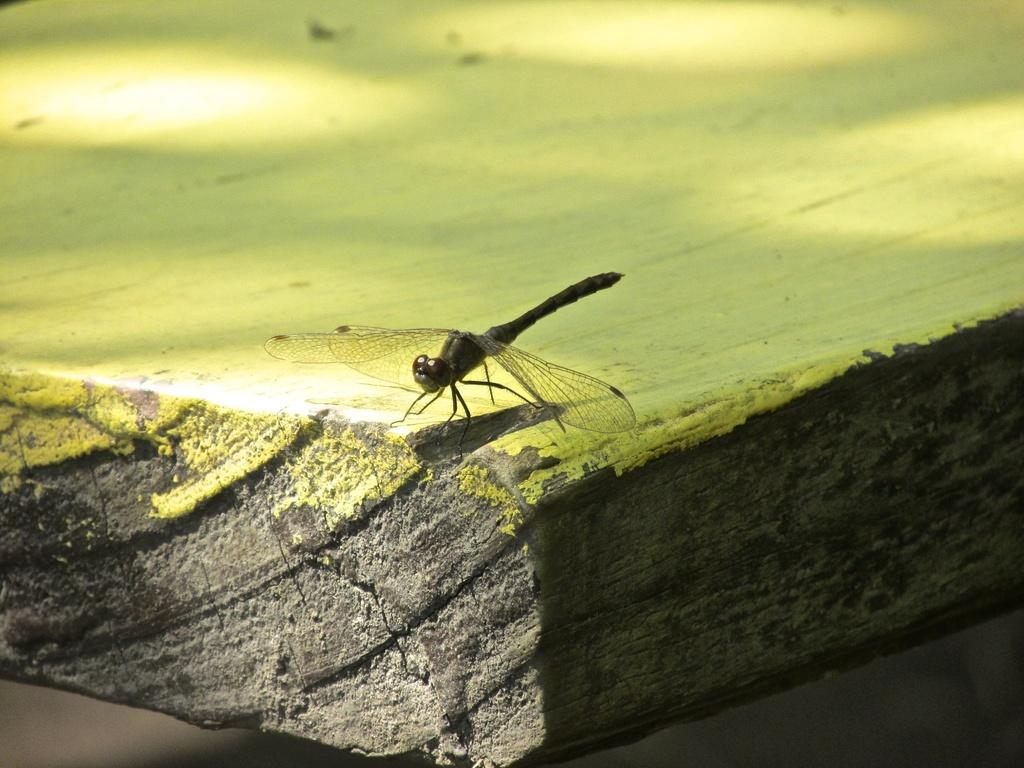What type of creature can be seen in the image? There is an insect in the image. What is the insect located on? The insect is on a wooden object. What type of vacation is the insect planning in the image? There is no indication in the image that the insect is planning a vacation, as insects do not plan vacations. 